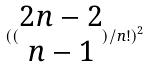Convert formula to latex. <formula><loc_0><loc_0><loc_500><loc_500>( ( \begin{matrix} 2 n - 2 \\ n - 1 \end{matrix} ) / n ! ) ^ { 2 }</formula> 